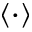<formula> <loc_0><loc_0><loc_500><loc_500>\langle \cdot \rangle</formula> 